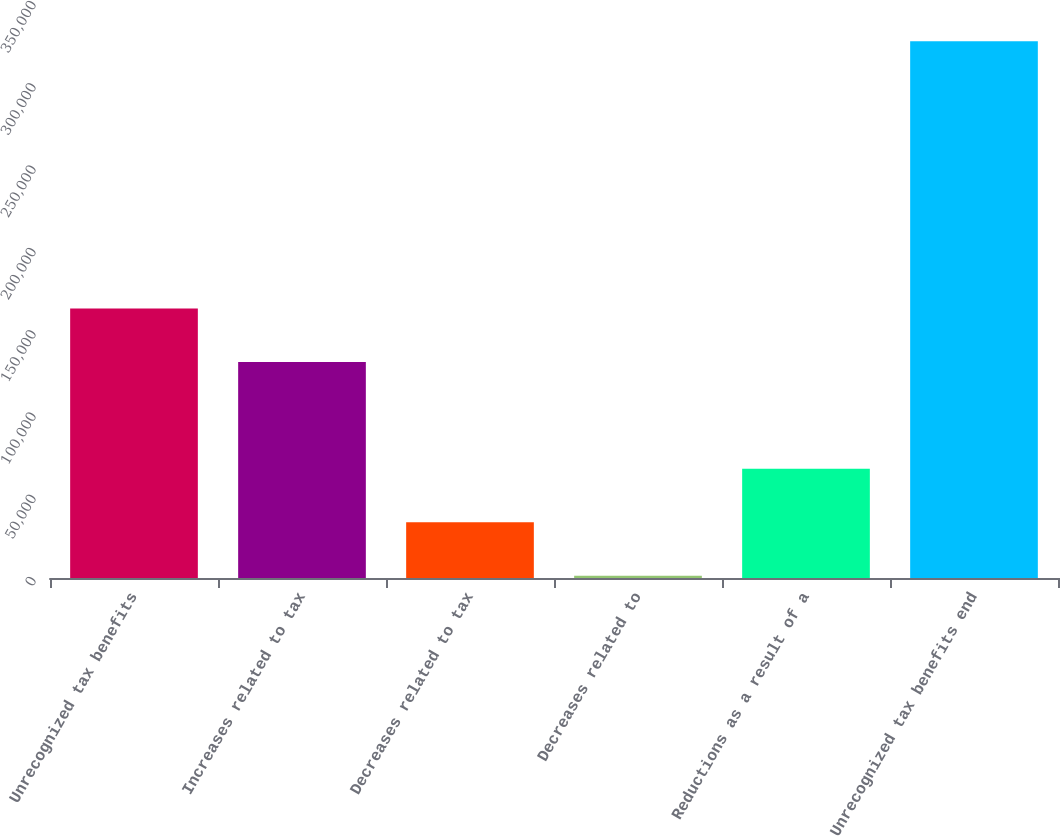Convert chart. <chart><loc_0><loc_0><loc_500><loc_500><bar_chart><fcel>Unrecognized tax benefits<fcel>Increases related to tax<fcel>Decreases related to tax<fcel>Decreases related to<fcel>Reductions as a result of a<fcel>Unrecognized tax benefits end<nl><fcel>163738<fcel>131269<fcel>33858.9<fcel>1389<fcel>66328.8<fcel>326088<nl></chart> 